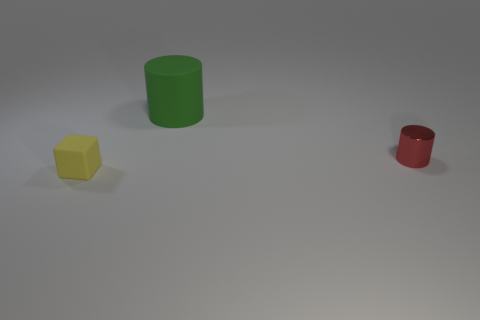Add 3 matte cylinders. How many objects exist? 6 Subtract all cylinders. How many objects are left? 1 Subtract 1 green cylinders. How many objects are left? 2 Subtract all purple cubes. Subtract all brown cylinders. How many cubes are left? 1 Subtract all small rubber cubes. Subtract all tiny yellow rubber things. How many objects are left? 1 Add 2 tiny yellow matte cubes. How many tiny yellow matte cubes are left? 3 Add 1 big things. How many big things exist? 2 